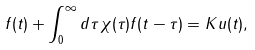Convert formula to latex. <formula><loc_0><loc_0><loc_500><loc_500>f ( t ) + \int _ { 0 } ^ { \infty } d \tau \, \chi ( \tau ) f ( t - \tau ) = K u ( t ) ,</formula> 